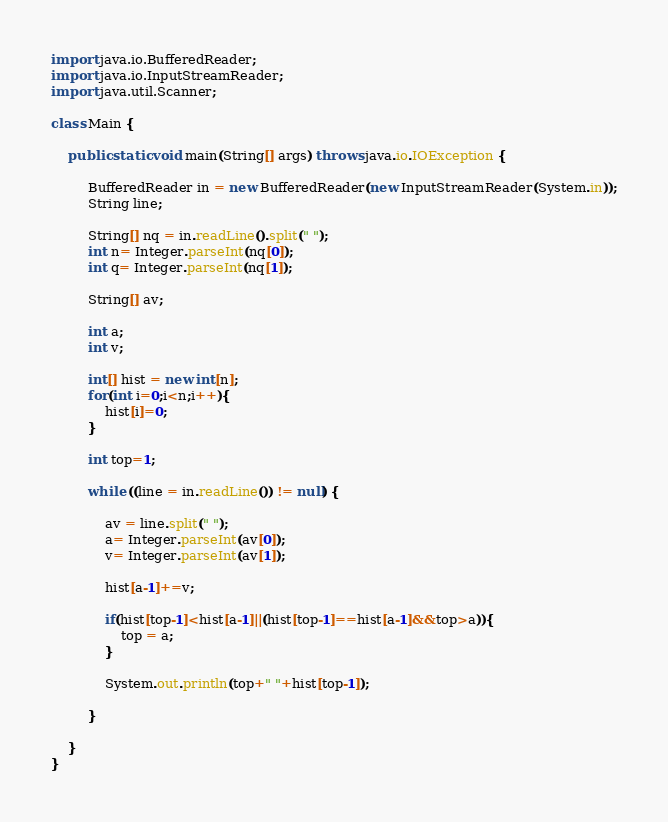<code> <loc_0><loc_0><loc_500><loc_500><_Java_>import java.io.BufferedReader;
import java.io.InputStreamReader;
import java.util.Scanner;

class Main {

	public static void main(String[] args) throws java.io.IOException {

		 BufferedReader in = new BufferedReader(new InputStreamReader(System.in));
		 String line;
		 
		 String[] nq = in.readLine().split(" ");
		 int n= Integer.parseInt(nq[0]);
		 int q= Integer.parseInt(nq[1]);
		
		 String[] av;
		 
		 int a;
		 int v;
		 
		 int[] hist = new int[n];
		 for(int i=0;i<n;i++){
			 hist[i]=0;
		 }
		 
		 int top=1;
		 
		 while ((line = in.readLine()) != null) {
		
			 av = line.split(" ");
			 a= Integer.parseInt(av[0]);
			 v= Integer.parseInt(av[1]);
			 
			 hist[a-1]+=v;
			 
			 if(hist[top-1]<hist[a-1]||(hist[top-1]==hist[a-1]&&top>a)){
				 top = a;
			 }
			
			 System.out.println(top+" "+hist[top-1]);
			 
		 }
		 
	}
}</code> 